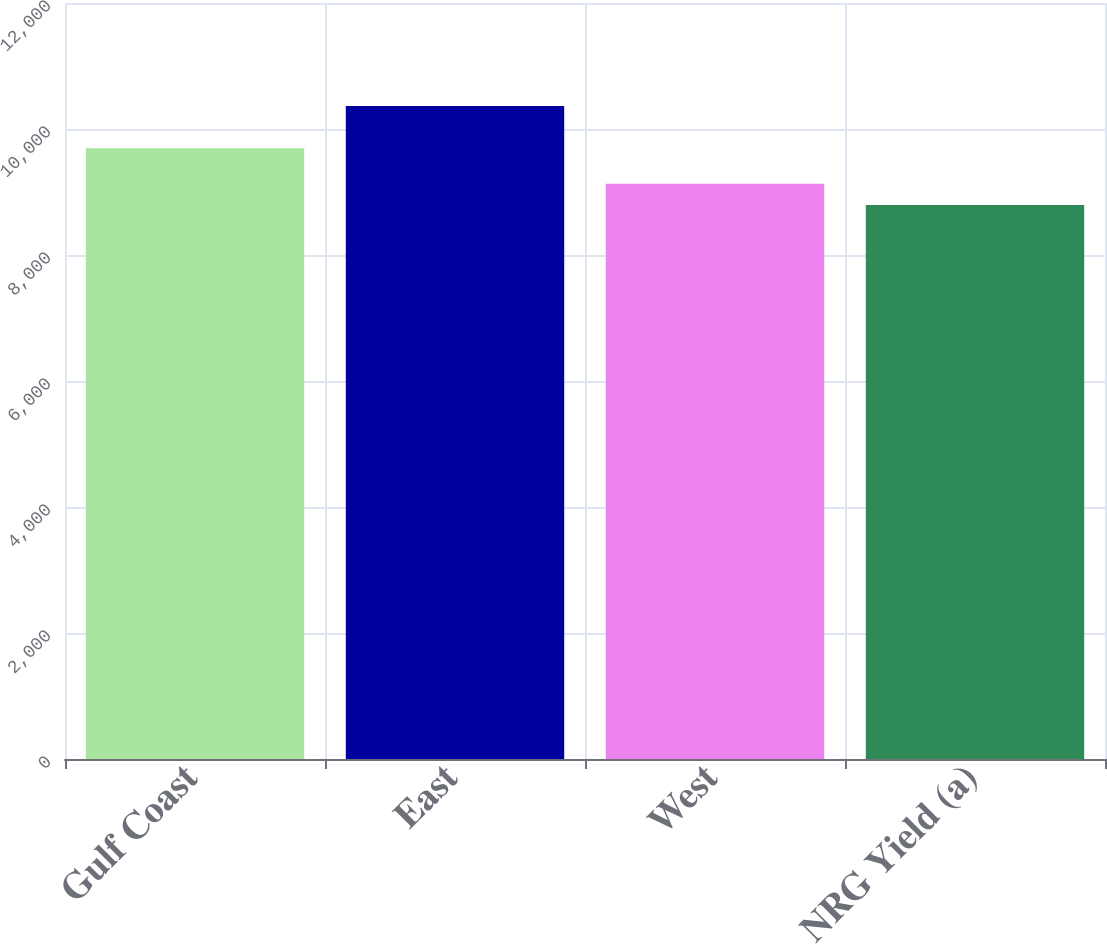<chart> <loc_0><loc_0><loc_500><loc_500><bar_chart><fcel>Gulf Coast<fcel>East<fcel>West<fcel>NRG Yield (a)<nl><fcel>9694<fcel>10367<fcel>9132<fcel>8794<nl></chart> 